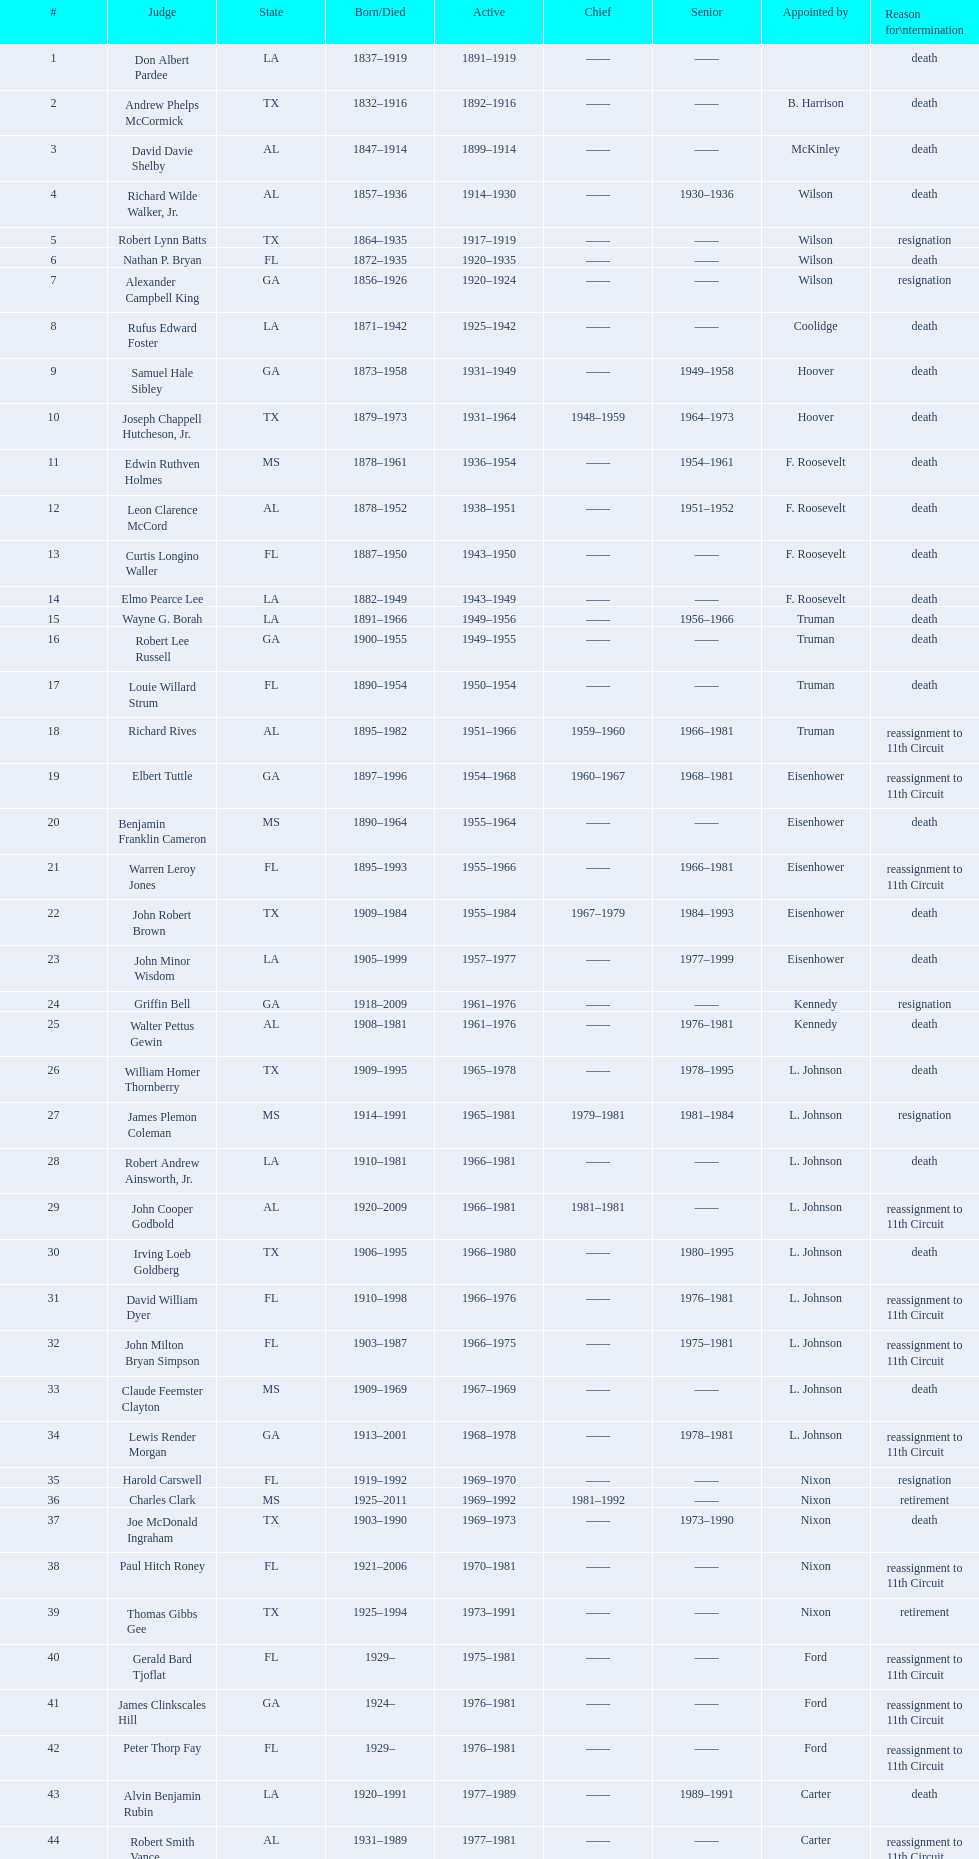President truman's last judge appointment was whom? Richard Rives. 